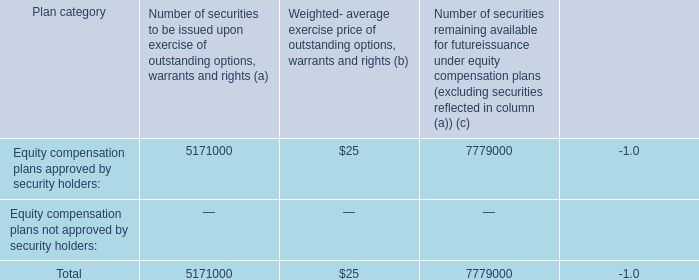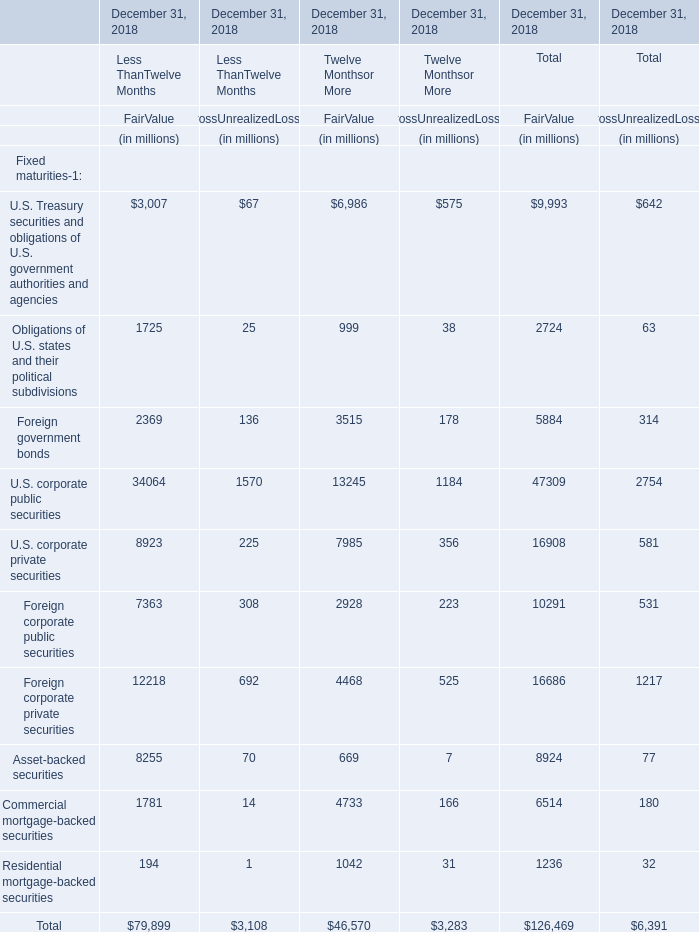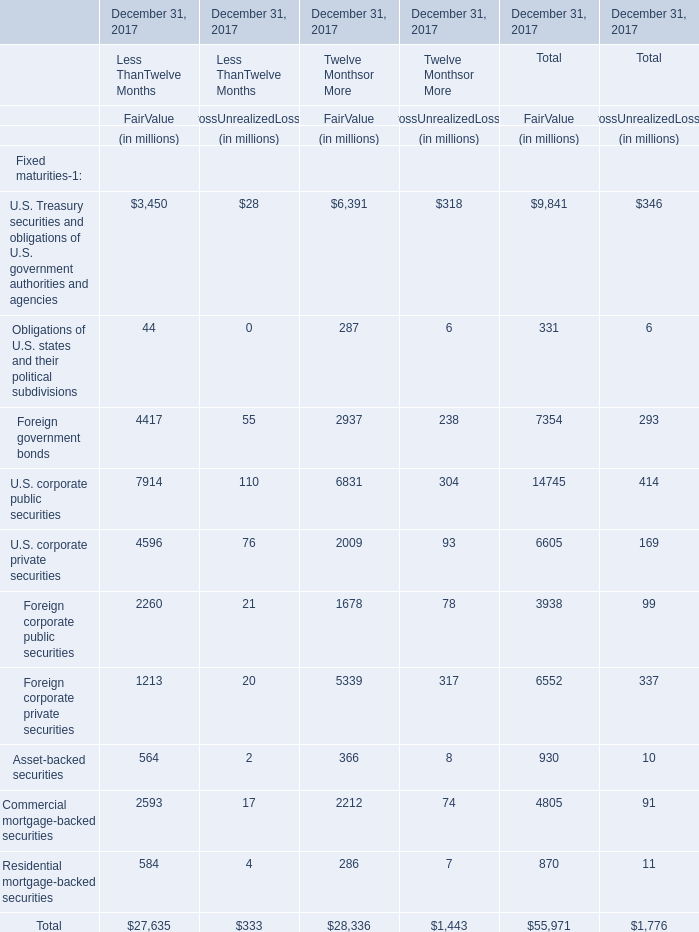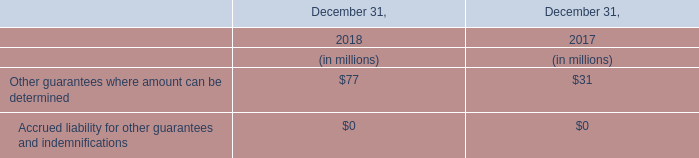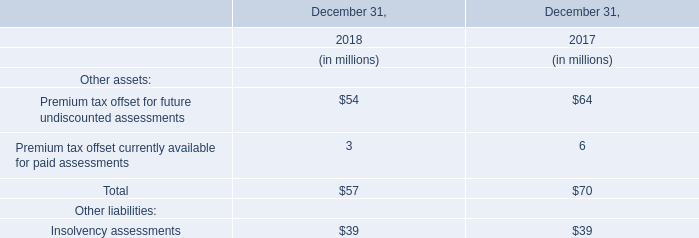Which element for FairValue of Total makes up more than 15 % of the total in 2017 
Answer: U.S. Treasury securities and obligations of U.S. government authorities and agencies,U.S. corporate public securities. 